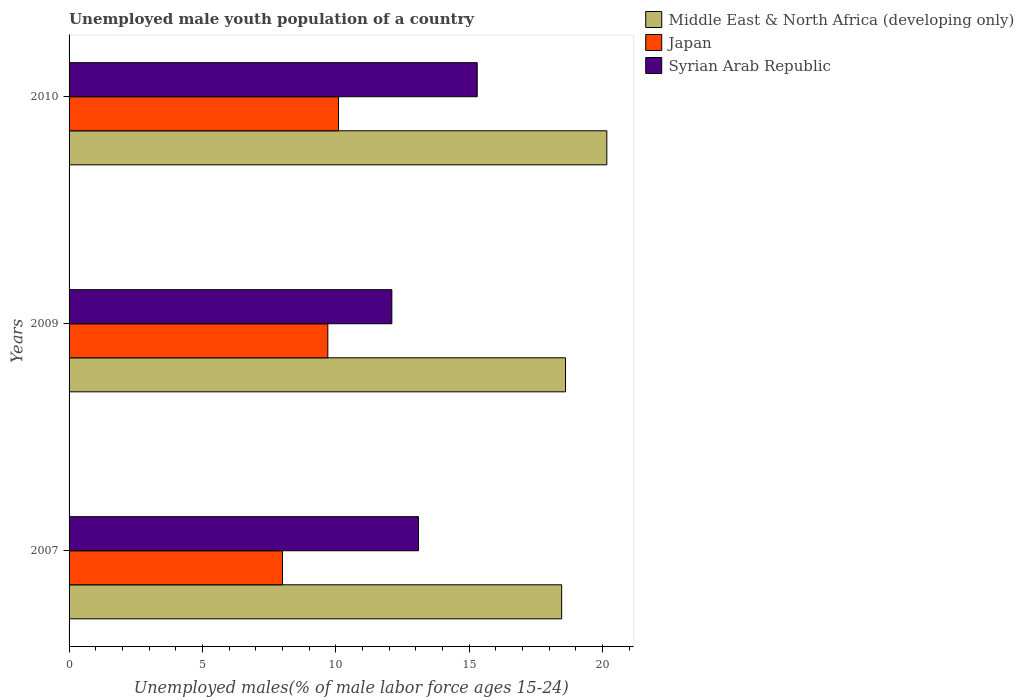Are the number of bars on each tick of the Y-axis equal?
Give a very brief answer. Yes. How many bars are there on the 3rd tick from the top?
Your answer should be compact. 3. What is the label of the 2nd group of bars from the top?
Ensure brevity in your answer.  2009. In how many cases, is the number of bars for a given year not equal to the number of legend labels?
Ensure brevity in your answer.  0. Across all years, what is the maximum percentage of unemployed male youth population in Middle East & North Africa (developing only)?
Make the answer very short. 20.16. Across all years, what is the minimum percentage of unemployed male youth population in Syrian Arab Republic?
Keep it short and to the point. 12.1. In which year was the percentage of unemployed male youth population in Middle East & North Africa (developing only) maximum?
Provide a short and direct response. 2010. What is the total percentage of unemployed male youth population in Syrian Arab Republic in the graph?
Your response must be concise. 40.5. What is the difference between the percentage of unemployed male youth population in Middle East & North Africa (developing only) in 2007 and that in 2010?
Your response must be concise. -1.69. What is the difference between the percentage of unemployed male youth population in Middle East & North Africa (developing only) in 2010 and the percentage of unemployed male youth population in Syrian Arab Republic in 2009?
Ensure brevity in your answer.  8.06. What is the average percentage of unemployed male youth population in Japan per year?
Your answer should be very brief. 9.27. In the year 2007, what is the difference between the percentage of unemployed male youth population in Japan and percentage of unemployed male youth population in Middle East & North Africa (developing only)?
Offer a very short reply. -10.47. In how many years, is the percentage of unemployed male youth population in Syrian Arab Republic greater than 10 %?
Give a very brief answer. 3. What is the ratio of the percentage of unemployed male youth population in Middle East & North Africa (developing only) in 2007 to that in 2010?
Offer a terse response. 0.92. Is the percentage of unemployed male youth population in Japan in 2009 less than that in 2010?
Offer a very short reply. Yes. Is the difference between the percentage of unemployed male youth population in Japan in 2009 and 2010 greater than the difference between the percentage of unemployed male youth population in Middle East & North Africa (developing only) in 2009 and 2010?
Offer a terse response. Yes. What is the difference between the highest and the second highest percentage of unemployed male youth population in Japan?
Your answer should be compact. 0.4. What is the difference between the highest and the lowest percentage of unemployed male youth population in Japan?
Make the answer very short. 2.1. In how many years, is the percentage of unemployed male youth population in Middle East & North Africa (developing only) greater than the average percentage of unemployed male youth population in Middle East & North Africa (developing only) taken over all years?
Offer a very short reply. 1. Is the sum of the percentage of unemployed male youth population in Middle East & North Africa (developing only) in 2007 and 2009 greater than the maximum percentage of unemployed male youth population in Japan across all years?
Provide a succinct answer. Yes. What does the 1st bar from the top in 2007 represents?
Your answer should be compact. Syrian Arab Republic. How many bars are there?
Offer a very short reply. 9. How many years are there in the graph?
Keep it short and to the point. 3. What is the difference between two consecutive major ticks on the X-axis?
Your answer should be compact. 5. Are the values on the major ticks of X-axis written in scientific E-notation?
Make the answer very short. No. Does the graph contain any zero values?
Make the answer very short. No. How many legend labels are there?
Your answer should be very brief. 3. How are the legend labels stacked?
Make the answer very short. Vertical. What is the title of the graph?
Make the answer very short. Unemployed male youth population of a country. Does "European Union" appear as one of the legend labels in the graph?
Provide a succinct answer. No. What is the label or title of the X-axis?
Your answer should be very brief. Unemployed males(% of male labor force ages 15-24). What is the label or title of the Y-axis?
Offer a terse response. Years. What is the Unemployed males(% of male labor force ages 15-24) in Middle East & North Africa (developing only) in 2007?
Offer a terse response. 18.47. What is the Unemployed males(% of male labor force ages 15-24) of Syrian Arab Republic in 2007?
Offer a terse response. 13.1. What is the Unemployed males(% of male labor force ages 15-24) in Middle East & North Africa (developing only) in 2009?
Provide a succinct answer. 18.61. What is the Unemployed males(% of male labor force ages 15-24) of Japan in 2009?
Provide a succinct answer. 9.7. What is the Unemployed males(% of male labor force ages 15-24) of Syrian Arab Republic in 2009?
Give a very brief answer. 12.1. What is the Unemployed males(% of male labor force ages 15-24) of Middle East & North Africa (developing only) in 2010?
Keep it short and to the point. 20.16. What is the Unemployed males(% of male labor force ages 15-24) in Japan in 2010?
Offer a terse response. 10.1. What is the Unemployed males(% of male labor force ages 15-24) in Syrian Arab Republic in 2010?
Offer a very short reply. 15.3. Across all years, what is the maximum Unemployed males(% of male labor force ages 15-24) of Middle East & North Africa (developing only)?
Keep it short and to the point. 20.16. Across all years, what is the maximum Unemployed males(% of male labor force ages 15-24) in Japan?
Your answer should be very brief. 10.1. Across all years, what is the maximum Unemployed males(% of male labor force ages 15-24) of Syrian Arab Republic?
Make the answer very short. 15.3. Across all years, what is the minimum Unemployed males(% of male labor force ages 15-24) of Middle East & North Africa (developing only)?
Provide a short and direct response. 18.47. Across all years, what is the minimum Unemployed males(% of male labor force ages 15-24) in Japan?
Offer a very short reply. 8. Across all years, what is the minimum Unemployed males(% of male labor force ages 15-24) of Syrian Arab Republic?
Give a very brief answer. 12.1. What is the total Unemployed males(% of male labor force ages 15-24) in Middle East & North Africa (developing only) in the graph?
Ensure brevity in your answer.  57.24. What is the total Unemployed males(% of male labor force ages 15-24) of Japan in the graph?
Keep it short and to the point. 27.8. What is the total Unemployed males(% of male labor force ages 15-24) in Syrian Arab Republic in the graph?
Ensure brevity in your answer.  40.5. What is the difference between the Unemployed males(% of male labor force ages 15-24) in Middle East & North Africa (developing only) in 2007 and that in 2009?
Your answer should be very brief. -0.15. What is the difference between the Unemployed males(% of male labor force ages 15-24) of Syrian Arab Republic in 2007 and that in 2009?
Your answer should be compact. 1. What is the difference between the Unemployed males(% of male labor force ages 15-24) of Middle East & North Africa (developing only) in 2007 and that in 2010?
Offer a very short reply. -1.69. What is the difference between the Unemployed males(% of male labor force ages 15-24) in Japan in 2007 and that in 2010?
Your response must be concise. -2.1. What is the difference between the Unemployed males(% of male labor force ages 15-24) in Syrian Arab Republic in 2007 and that in 2010?
Give a very brief answer. -2.2. What is the difference between the Unemployed males(% of male labor force ages 15-24) in Middle East & North Africa (developing only) in 2009 and that in 2010?
Keep it short and to the point. -1.55. What is the difference between the Unemployed males(% of male labor force ages 15-24) in Syrian Arab Republic in 2009 and that in 2010?
Give a very brief answer. -3.2. What is the difference between the Unemployed males(% of male labor force ages 15-24) in Middle East & North Africa (developing only) in 2007 and the Unemployed males(% of male labor force ages 15-24) in Japan in 2009?
Keep it short and to the point. 8.77. What is the difference between the Unemployed males(% of male labor force ages 15-24) in Middle East & North Africa (developing only) in 2007 and the Unemployed males(% of male labor force ages 15-24) in Syrian Arab Republic in 2009?
Offer a terse response. 6.37. What is the difference between the Unemployed males(% of male labor force ages 15-24) in Japan in 2007 and the Unemployed males(% of male labor force ages 15-24) in Syrian Arab Republic in 2009?
Ensure brevity in your answer.  -4.1. What is the difference between the Unemployed males(% of male labor force ages 15-24) of Middle East & North Africa (developing only) in 2007 and the Unemployed males(% of male labor force ages 15-24) of Japan in 2010?
Give a very brief answer. 8.37. What is the difference between the Unemployed males(% of male labor force ages 15-24) of Middle East & North Africa (developing only) in 2007 and the Unemployed males(% of male labor force ages 15-24) of Syrian Arab Republic in 2010?
Make the answer very short. 3.17. What is the difference between the Unemployed males(% of male labor force ages 15-24) of Japan in 2007 and the Unemployed males(% of male labor force ages 15-24) of Syrian Arab Republic in 2010?
Give a very brief answer. -7.3. What is the difference between the Unemployed males(% of male labor force ages 15-24) in Middle East & North Africa (developing only) in 2009 and the Unemployed males(% of male labor force ages 15-24) in Japan in 2010?
Ensure brevity in your answer.  8.51. What is the difference between the Unemployed males(% of male labor force ages 15-24) of Middle East & North Africa (developing only) in 2009 and the Unemployed males(% of male labor force ages 15-24) of Syrian Arab Republic in 2010?
Keep it short and to the point. 3.31. What is the average Unemployed males(% of male labor force ages 15-24) in Middle East & North Africa (developing only) per year?
Provide a short and direct response. 19.08. What is the average Unemployed males(% of male labor force ages 15-24) of Japan per year?
Keep it short and to the point. 9.27. In the year 2007, what is the difference between the Unemployed males(% of male labor force ages 15-24) of Middle East & North Africa (developing only) and Unemployed males(% of male labor force ages 15-24) of Japan?
Give a very brief answer. 10.47. In the year 2007, what is the difference between the Unemployed males(% of male labor force ages 15-24) of Middle East & North Africa (developing only) and Unemployed males(% of male labor force ages 15-24) of Syrian Arab Republic?
Offer a very short reply. 5.37. In the year 2009, what is the difference between the Unemployed males(% of male labor force ages 15-24) of Middle East & North Africa (developing only) and Unemployed males(% of male labor force ages 15-24) of Japan?
Make the answer very short. 8.91. In the year 2009, what is the difference between the Unemployed males(% of male labor force ages 15-24) in Middle East & North Africa (developing only) and Unemployed males(% of male labor force ages 15-24) in Syrian Arab Republic?
Give a very brief answer. 6.51. In the year 2010, what is the difference between the Unemployed males(% of male labor force ages 15-24) of Middle East & North Africa (developing only) and Unemployed males(% of male labor force ages 15-24) of Japan?
Your answer should be very brief. 10.06. In the year 2010, what is the difference between the Unemployed males(% of male labor force ages 15-24) in Middle East & North Africa (developing only) and Unemployed males(% of male labor force ages 15-24) in Syrian Arab Republic?
Give a very brief answer. 4.86. What is the ratio of the Unemployed males(% of male labor force ages 15-24) of Middle East & North Africa (developing only) in 2007 to that in 2009?
Make the answer very short. 0.99. What is the ratio of the Unemployed males(% of male labor force ages 15-24) of Japan in 2007 to that in 2009?
Your response must be concise. 0.82. What is the ratio of the Unemployed males(% of male labor force ages 15-24) in Syrian Arab Republic in 2007 to that in 2009?
Your answer should be very brief. 1.08. What is the ratio of the Unemployed males(% of male labor force ages 15-24) of Middle East & North Africa (developing only) in 2007 to that in 2010?
Your response must be concise. 0.92. What is the ratio of the Unemployed males(% of male labor force ages 15-24) in Japan in 2007 to that in 2010?
Offer a very short reply. 0.79. What is the ratio of the Unemployed males(% of male labor force ages 15-24) in Syrian Arab Republic in 2007 to that in 2010?
Offer a very short reply. 0.86. What is the ratio of the Unemployed males(% of male labor force ages 15-24) of Middle East & North Africa (developing only) in 2009 to that in 2010?
Make the answer very short. 0.92. What is the ratio of the Unemployed males(% of male labor force ages 15-24) of Japan in 2009 to that in 2010?
Keep it short and to the point. 0.96. What is the ratio of the Unemployed males(% of male labor force ages 15-24) in Syrian Arab Republic in 2009 to that in 2010?
Provide a short and direct response. 0.79. What is the difference between the highest and the second highest Unemployed males(% of male labor force ages 15-24) in Middle East & North Africa (developing only)?
Provide a short and direct response. 1.55. What is the difference between the highest and the second highest Unemployed males(% of male labor force ages 15-24) in Japan?
Your answer should be compact. 0.4. What is the difference between the highest and the lowest Unemployed males(% of male labor force ages 15-24) of Middle East & North Africa (developing only)?
Offer a very short reply. 1.69. What is the difference between the highest and the lowest Unemployed males(% of male labor force ages 15-24) of Syrian Arab Republic?
Provide a succinct answer. 3.2. 